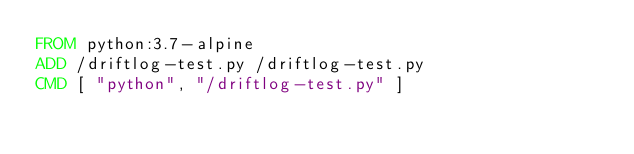Convert code to text. <code><loc_0><loc_0><loc_500><loc_500><_Dockerfile_>FROM python:3.7-alpine
ADD /driftlog-test.py /driftlog-test.py
CMD [ "python", "/driftlog-test.py" ]
</code> 